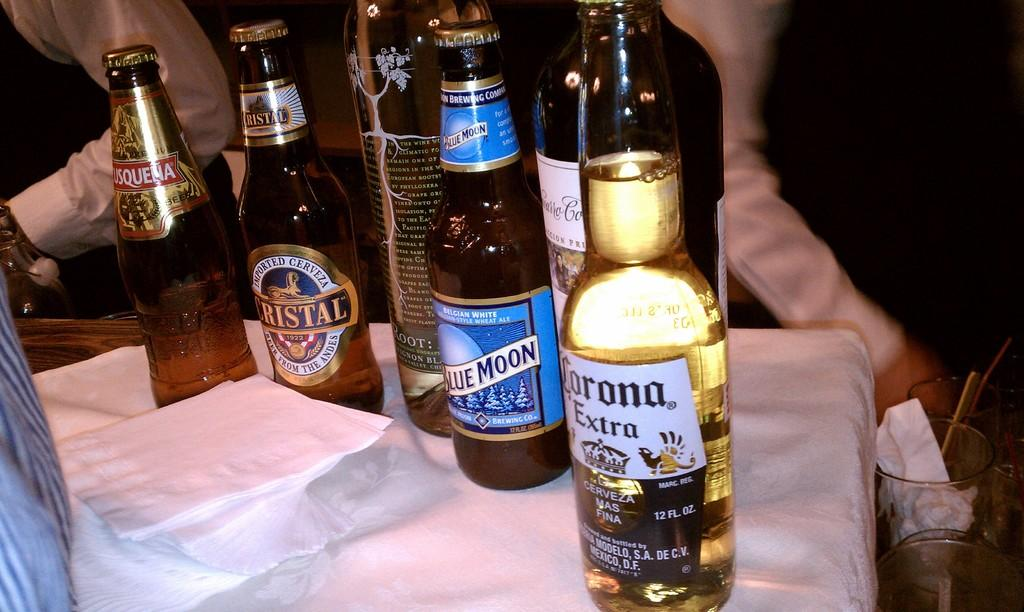<image>
Relay a brief, clear account of the picture shown. Bottles of beer including a Corona sit on a table 